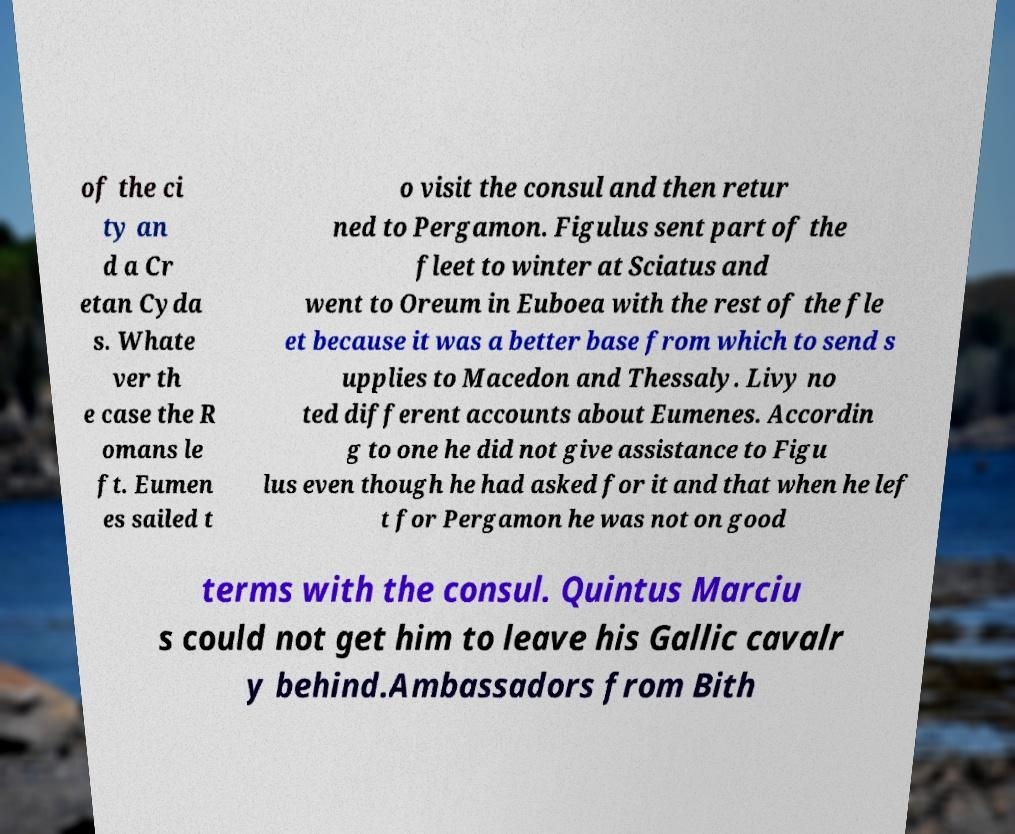What messages or text are displayed in this image? I need them in a readable, typed format. of the ci ty an d a Cr etan Cyda s. Whate ver th e case the R omans le ft. Eumen es sailed t o visit the consul and then retur ned to Pergamon. Figulus sent part of the fleet to winter at Sciatus and went to Oreum in Euboea with the rest of the fle et because it was a better base from which to send s upplies to Macedon and Thessaly. Livy no ted different accounts about Eumenes. Accordin g to one he did not give assistance to Figu lus even though he had asked for it and that when he lef t for Pergamon he was not on good terms with the consul. Quintus Marciu s could not get him to leave his Gallic cavalr y behind.Ambassadors from Bith 